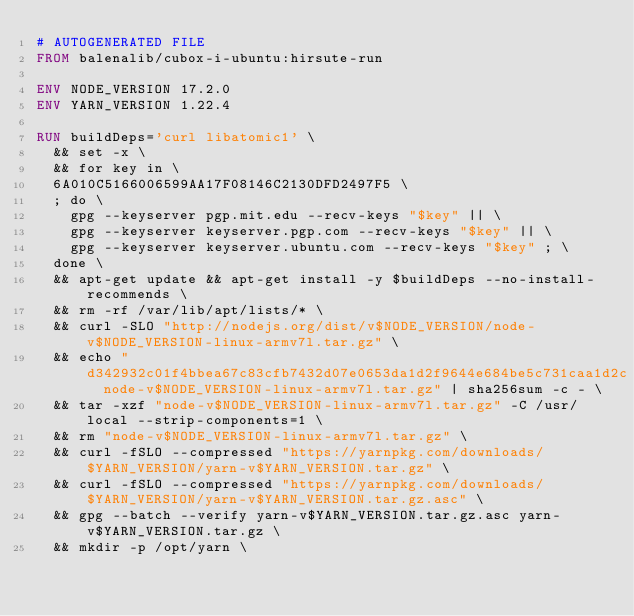Convert code to text. <code><loc_0><loc_0><loc_500><loc_500><_Dockerfile_># AUTOGENERATED FILE
FROM balenalib/cubox-i-ubuntu:hirsute-run

ENV NODE_VERSION 17.2.0
ENV YARN_VERSION 1.22.4

RUN buildDeps='curl libatomic1' \
	&& set -x \
	&& for key in \
	6A010C5166006599AA17F08146C2130DFD2497F5 \
	; do \
		gpg --keyserver pgp.mit.edu --recv-keys "$key" || \
		gpg --keyserver keyserver.pgp.com --recv-keys "$key" || \
		gpg --keyserver keyserver.ubuntu.com --recv-keys "$key" ; \
	done \
	&& apt-get update && apt-get install -y $buildDeps --no-install-recommends \
	&& rm -rf /var/lib/apt/lists/* \
	&& curl -SLO "http://nodejs.org/dist/v$NODE_VERSION/node-v$NODE_VERSION-linux-armv7l.tar.gz" \
	&& echo "d342932c01f4bbea67c83cfb7432d07e0653da1d2f9644e684be5c731caa1d2c  node-v$NODE_VERSION-linux-armv7l.tar.gz" | sha256sum -c - \
	&& tar -xzf "node-v$NODE_VERSION-linux-armv7l.tar.gz" -C /usr/local --strip-components=1 \
	&& rm "node-v$NODE_VERSION-linux-armv7l.tar.gz" \
	&& curl -fSLO --compressed "https://yarnpkg.com/downloads/$YARN_VERSION/yarn-v$YARN_VERSION.tar.gz" \
	&& curl -fSLO --compressed "https://yarnpkg.com/downloads/$YARN_VERSION/yarn-v$YARN_VERSION.tar.gz.asc" \
	&& gpg --batch --verify yarn-v$YARN_VERSION.tar.gz.asc yarn-v$YARN_VERSION.tar.gz \
	&& mkdir -p /opt/yarn \</code> 